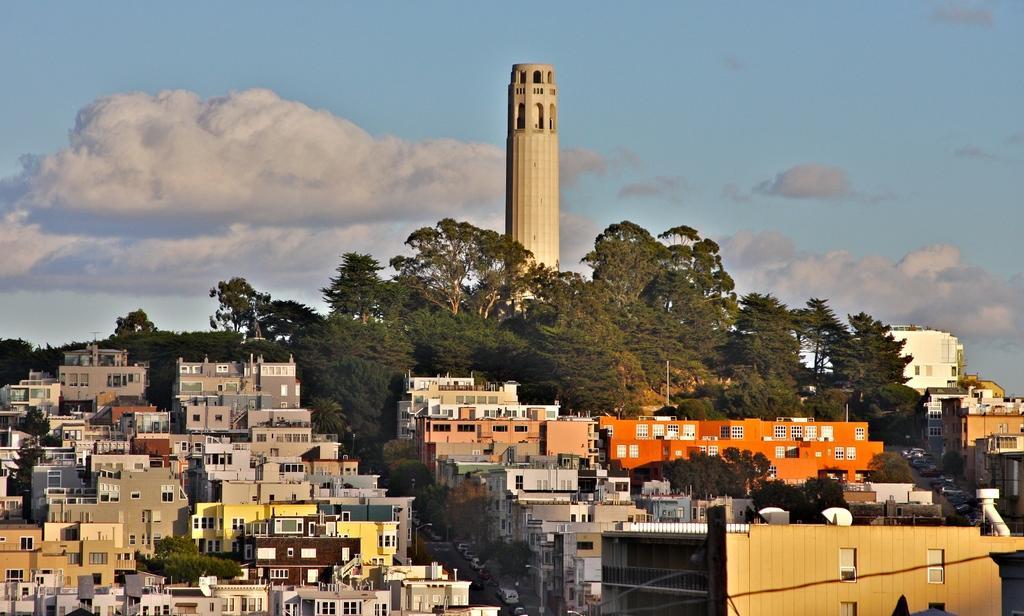In one or two sentences, can you explain what this image depicts? In this image there are so many buildings. We can see two roads in the middle of the buildings. There are vehicles. There is a tall building on the background. There are trees. There are clouds in the sky. 